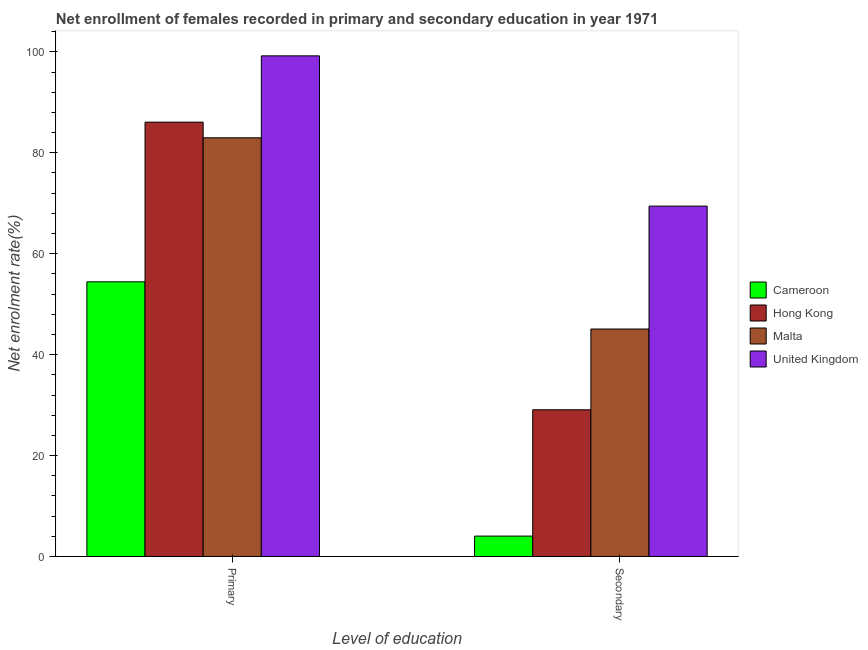How many groups of bars are there?
Offer a terse response. 2. How many bars are there on the 2nd tick from the left?
Make the answer very short. 4. How many bars are there on the 1st tick from the right?
Your answer should be very brief. 4. What is the label of the 1st group of bars from the left?
Offer a terse response. Primary. What is the enrollment rate in secondary education in Hong Kong?
Your response must be concise. 29.07. Across all countries, what is the maximum enrollment rate in secondary education?
Provide a short and direct response. 69.43. Across all countries, what is the minimum enrollment rate in secondary education?
Your answer should be very brief. 4.05. In which country was the enrollment rate in primary education maximum?
Your answer should be compact. United Kingdom. In which country was the enrollment rate in primary education minimum?
Provide a succinct answer. Cameroon. What is the total enrollment rate in secondary education in the graph?
Your response must be concise. 147.63. What is the difference between the enrollment rate in secondary education in Hong Kong and that in United Kingdom?
Keep it short and to the point. -40.35. What is the difference between the enrollment rate in secondary education in Hong Kong and the enrollment rate in primary education in Cameroon?
Offer a terse response. -25.35. What is the average enrollment rate in secondary education per country?
Your response must be concise. 36.91. What is the difference between the enrollment rate in secondary education and enrollment rate in primary education in Hong Kong?
Provide a short and direct response. -56.99. In how many countries, is the enrollment rate in secondary education greater than 68 %?
Offer a terse response. 1. What is the ratio of the enrollment rate in secondary education in Cameroon to that in Hong Kong?
Offer a very short reply. 0.14. Is the enrollment rate in primary education in United Kingdom less than that in Cameroon?
Give a very brief answer. No. What does the 3rd bar from the right in Secondary represents?
Your response must be concise. Hong Kong. Are all the bars in the graph horizontal?
Provide a short and direct response. No. Are the values on the major ticks of Y-axis written in scientific E-notation?
Ensure brevity in your answer.  No. Does the graph contain any zero values?
Provide a succinct answer. No. Does the graph contain grids?
Offer a terse response. No. Where does the legend appear in the graph?
Offer a very short reply. Center right. How many legend labels are there?
Provide a short and direct response. 4. How are the legend labels stacked?
Offer a terse response. Vertical. What is the title of the graph?
Provide a succinct answer. Net enrollment of females recorded in primary and secondary education in year 1971. Does "Albania" appear as one of the legend labels in the graph?
Your answer should be very brief. No. What is the label or title of the X-axis?
Provide a short and direct response. Level of education. What is the label or title of the Y-axis?
Keep it short and to the point. Net enrolment rate(%). What is the Net enrolment rate(%) in Cameroon in Primary?
Offer a very short reply. 54.43. What is the Net enrolment rate(%) of Hong Kong in Primary?
Make the answer very short. 86.07. What is the Net enrolment rate(%) in Malta in Primary?
Give a very brief answer. 82.96. What is the Net enrolment rate(%) of United Kingdom in Primary?
Offer a very short reply. 99.2. What is the Net enrolment rate(%) of Cameroon in Secondary?
Ensure brevity in your answer.  4.05. What is the Net enrolment rate(%) of Hong Kong in Secondary?
Make the answer very short. 29.07. What is the Net enrolment rate(%) of Malta in Secondary?
Keep it short and to the point. 45.08. What is the Net enrolment rate(%) in United Kingdom in Secondary?
Offer a terse response. 69.43. Across all Level of education, what is the maximum Net enrolment rate(%) in Cameroon?
Offer a terse response. 54.43. Across all Level of education, what is the maximum Net enrolment rate(%) in Hong Kong?
Ensure brevity in your answer.  86.07. Across all Level of education, what is the maximum Net enrolment rate(%) in Malta?
Your answer should be compact. 82.96. Across all Level of education, what is the maximum Net enrolment rate(%) of United Kingdom?
Your response must be concise. 99.2. Across all Level of education, what is the minimum Net enrolment rate(%) in Cameroon?
Your answer should be compact. 4.05. Across all Level of education, what is the minimum Net enrolment rate(%) of Hong Kong?
Offer a very short reply. 29.07. Across all Level of education, what is the minimum Net enrolment rate(%) of Malta?
Provide a short and direct response. 45.08. Across all Level of education, what is the minimum Net enrolment rate(%) of United Kingdom?
Your answer should be compact. 69.43. What is the total Net enrolment rate(%) of Cameroon in the graph?
Ensure brevity in your answer.  58.48. What is the total Net enrolment rate(%) of Hong Kong in the graph?
Make the answer very short. 115.14. What is the total Net enrolment rate(%) in Malta in the graph?
Keep it short and to the point. 128.04. What is the total Net enrolment rate(%) in United Kingdom in the graph?
Your answer should be compact. 168.63. What is the difference between the Net enrolment rate(%) of Cameroon in Primary and that in Secondary?
Offer a very short reply. 50.38. What is the difference between the Net enrolment rate(%) in Hong Kong in Primary and that in Secondary?
Make the answer very short. 56.99. What is the difference between the Net enrolment rate(%) of Malta in Primary and that in Secondary?
Ensure brevity in your answer.  37.89. What is the difference between the Net enrolment rate(%) of United Kingdom in Primary and that in Secondary?
Your answer should be compact. 29.77. What is the difference between the Net enrolment rate(%) in Cameroon in Primary and the Net enrolment rate(%) in Hong Kong in Secondary?
Provide a short and direct response. 25.35. What is the difference between the Net enrolment rate(%) of Cameroon in Primary and the Net enrolment rate(%) of Malta in Secondary?
Keep it short and to the point. 9.35. What is the difference between the Net enrolment rate(%) of Cameroon in Primary and the Net enrolment rate(%) of United Kingdom in Secondary?
Your answer should be compact. -15. What is the difference between the Net enrolment rate(%) of Hong Kong in Primary and the Net enrolment rate(%) of Malta in Secondary?
Ensure brevity in your answer.  40.99. What is the difference between the Net enrolment rate(%) in Hong Kong in Primary and the Net enrolment rate(%) in United Kingdom in Secondary?
Keep it short and to the point. 16.64. What is the difference between the Net enrolment rate(%) in Malta in Primary and the Net enrolment rate(%) in United Kingdom in Secondary?
Ensure brevity in your answer.  13.54. What is the average Net enrolment rate(%) of Cameroon per Level of education?
Keep it short and to the point. 29.24. What is the average Net enrolment rate(%) of Hong Kong per Level of education?
Your response must be concise. 57.57. What is the average Net enrolment rate(%) of Malta per Level of education?
Make the answer very short. 64.02. What is the average Net enrolment rate(%) of United Kingdom per Level of education?
Offer a terse response. 84.31. What is the difference between the Net enrolment rate(%) in Cameroon and Net enrolment rate(%) in Hong Kong in Primary?
Make the answer very short. -31.64. What is the difference between the Net enrolment rate(%) of Cameroon and Net enrolment rate(%) of Malta in Primary?
Make the answer very short. -28.54. What is the difference between the Net enrolment rate(%) in Cameroon and Net enrolment rate(%) in United Kingdom in Primary?
Offer a terse response. -44.77. What is the difference between the Net enrolment rate(%) of Hong Kong and Net enrolment rate(%) of Malta in Primary?
Make the answer very short. 3.1. What is the difference between the Net enrolment rate(%) of Hong Kong and Net enrolment rate(%) of United Kingdom in Primary?
Make the answer very short. -13.13. What is the difference between the Net enrolment rate(%) of Malta and Net enrolment rate(%) of United Kingdom in Primary?
Ensure brevity in your answer.  -16.24. What is the difference between the Net enrolment rate(%) in Cameroon and Net enrolment rate(%) in Hong Kong in Secondary?
Your response must be concise. -25.02. What is the difference between the Net enrolment rate(%) of Cameroon and Net enrolment rate(%) of Malta in Secondary?
Your response must be concise. -41.03. What is the difference between the Net enrolment rate(%) of Cameroon and Net enrolment rate(%) of United Kingdom in Secondary?
Make the answer very short. -65.38. What is the difference between the Net enrolment rate(%) in Hong Kong and Net enrolment rate(%) in Malta in Secondary?
Keep it short and to the point. -16. What is the difference between the Net enrolment rate(%) of Hong Kong and Net enrolment rate(%) of United Kingdom in Secondary?
Offer a very short reply. -40.35. What is the difference between the Net enrolment rate(%) of Malta and Net enrolment rate(%) of United Kingdom in Secondary?
Provide a short and direct response. -24.35. What is the ratio of the Net enrolment rate(%) in Cameroon in Primary to that in Secondary?
Ensure brevity in your answer.  13.44. What is the ratio of the Net enrolment rate(%) of Hong Kong in Primary to that in Secondary?
Give a very brief answer. 2.96. What is the ratio of the Net enrolment rate(%) of Malta in Primary to that in Secondary?
Provide a short and direct response. 1.84. What is the ratio of the Net enrolment rate(%) of United Kingdom in Primary to that in Secondary?
Offer a terse response. 1.43. What is the difference between the highest and the second highest Net enrolment rate(%) in Cameroon?
Your answer should be very brief. 50.38. What is the difference between the highest and the second highest Net enrolment rate(%) in Hong Kong?
Offer a very short reply. 56.99. What is the difference between the highest and the second highest Net enrolment rate(%) of Malta?
Offer a very short reply. 37.89. What is the difference between the highest and the second highest Net enrolment rate(%) in United Kingdom?
Provide a succinct answer. 29.77. What is the difference between the highest and the lowest Net enrolment rate(%) in Cameroon?
Keep it short and to the point. 50.38. What is the difference between the highest and the lowest Net enrolment rate(%) in Hong Kong?
Your response must be concise. 56.99. What is the difference between the highest and the lowest Net enrolment rate(%) in Malta?
Give a very brief answer. 37.89. What is the difference between the highest and the lowest Net enrolment rate(%) in United Kingdom?
Ensure brevity in your answer.  29.77. 